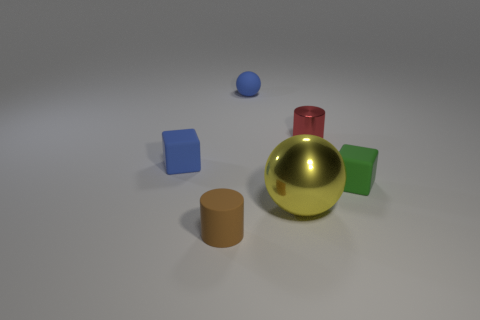How many big balls are the same color as the small metallic cylinder?
Your response must be concise. 0. There is a thing that is in front of the small green matte block and behind the tiny brown matte object; what is its size?
Provide a short and direct response. Large. Are there fewer large metal things behind the yellow shiny thing than purple rubber blocks?
Provide a short and direct response. No. Does the brown cylinder have the same material as the small red cylinder?
Make the answer very short. No. How many objects are either cyan spheres or blue matte things?
Your response must be concise. 2. How many tiny red objects have the same material as the big object?
Give a very brief answer. 1. What size is the rubber thing that is the same shape as the red metallic object?
Provide a succinct answer. Small. There is a matte ball; are there any small red objects in front of it?
Offer a very short reply. Yes. What is the material of the brown cylinder?
Your answer should be compact. Rubber. There is a small rubber object that is in front of the green cube; does it have the same color as the small shiny cylinder?
Ensure brevity in your answer.  No. 